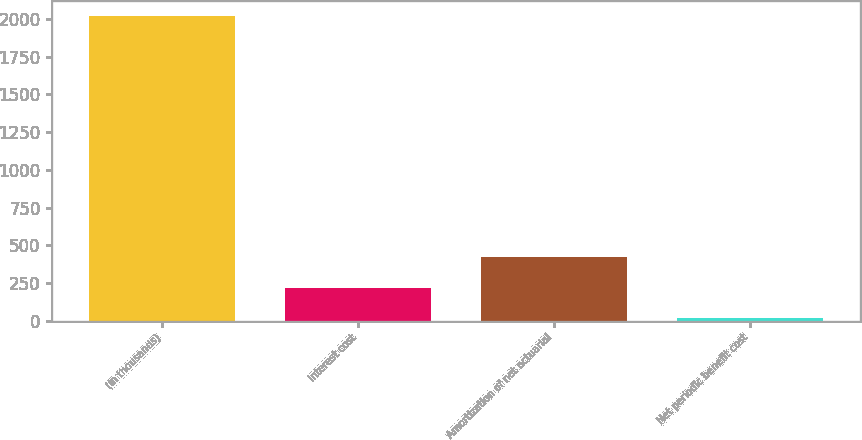Convert chart. <chart><loc_0><loc_0><loc_500><loc_500><bar_chart><fcel>(In thousands)<fcel>Interest cost<fcel>Amortization of net actuarial<fcel>Net periodic benefit cost<nl><fcel>2015<fcel>219.5<fcel>419<fcel>20<nl></chart> 